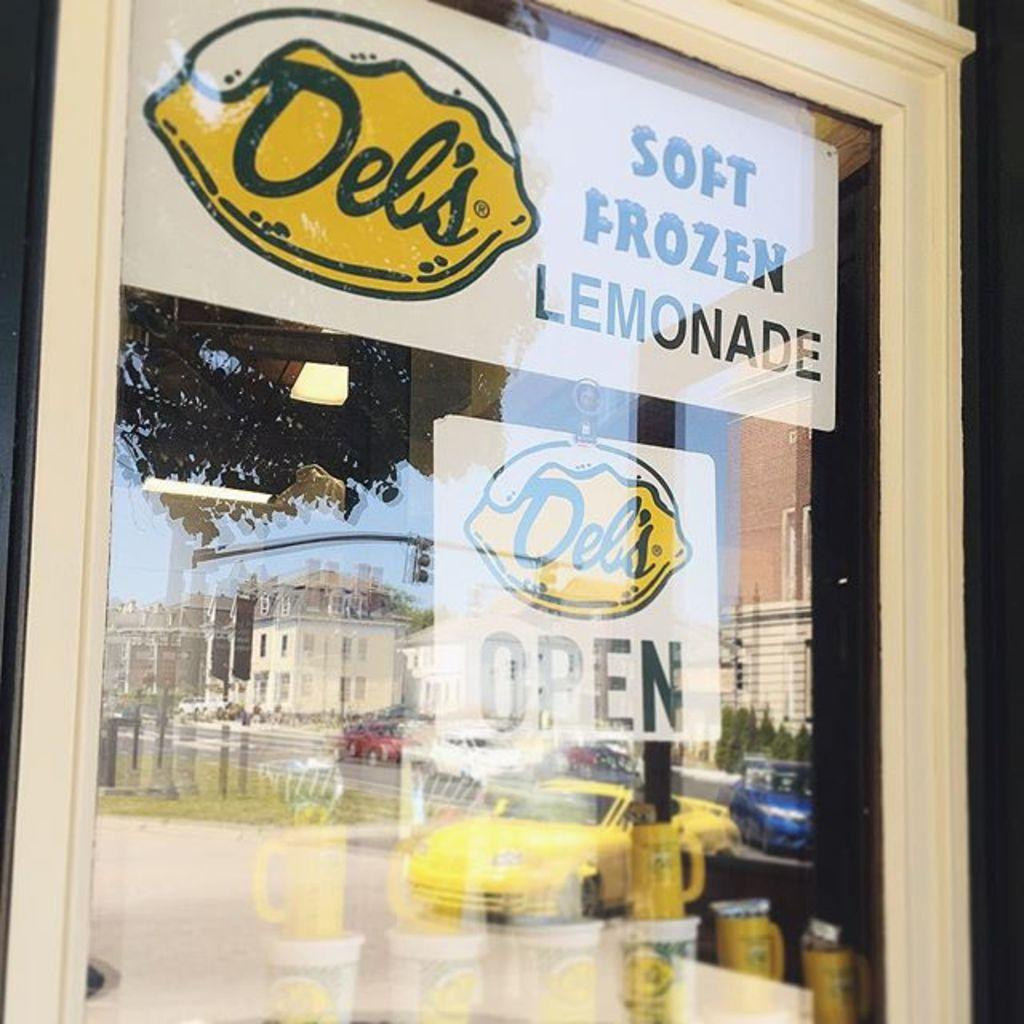<image>
Summarize the visual content of the image. The store is open and sales soft frozen lemonade. 